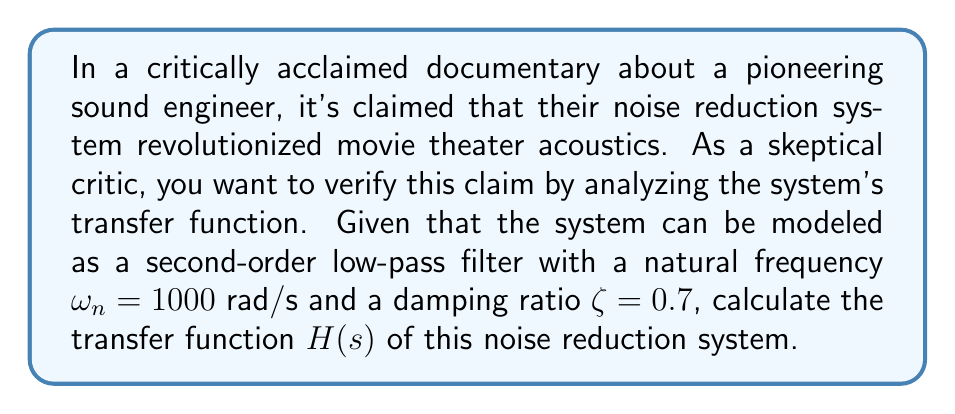Teach me how to tackle this problem. To calculate the transfer function of the noise reduction system, we'll follow these steps:

1) The general form of a second-order low-pass filter transfer function is:

   $$H(s) = \frac{\omega_n^2}{s^2 + 2\zeta\omega_n s + \omega_n^2}$$

2) We're given:
   $\omega_n = 1000$ rad/s
   $\zeta = 0.7$

3) Substituting these values into the general form:

   $$H(s) = \frac{1000^2}{s^2 + 2(0.7)(1000)s + 1000^2}$$

4) Simplify:
   $$H(s) = \frac{1,000,000}{s^2 + 1400s + 1,000,000}$$

This transfer function represents how the system modifies the amplitude and phase of input signals at different frequencies. It attenuates high-frequency noise while allowing lower frequencies (typically containing the desired audio) to pass through.

The natural frequency $\omega_n = 1000$ rad/s (about 159 Hz) represents the system's cutoff frequency, above which signals start to be attenuated. The damping ratio $\zeta = 0.7$ indicates that the system is underdamped, providing a good balance between quick response and minimal overshoot.

As a skeptical critic, you might note that while this transfer function does describe a functional noise reduction system, whether it truly "revolutionized" movie theater acoustics would depend on comparing its performance to other systems of its time and evaluating its practical impact on the movie-going experience.
Answer: $$H(s) = \frac{1,000,000}{s^2 + 1400s + 1,000,000}$$ 